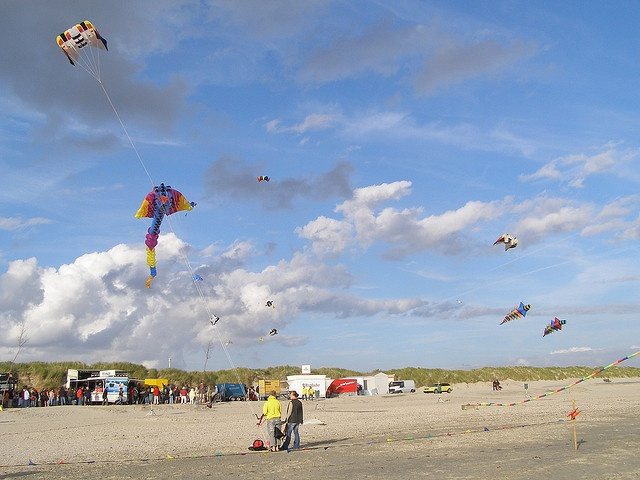Describe the objects in this image and their specific colors. I can see people in gray, black, maroon, and olive tones, kite in gray, darkgray, purple, and olive tones, kite in gray, black, and darkgray tones, people in gray, khaki, darkgray, and black tones, and people in gray, black, and maroon tones in this image. 